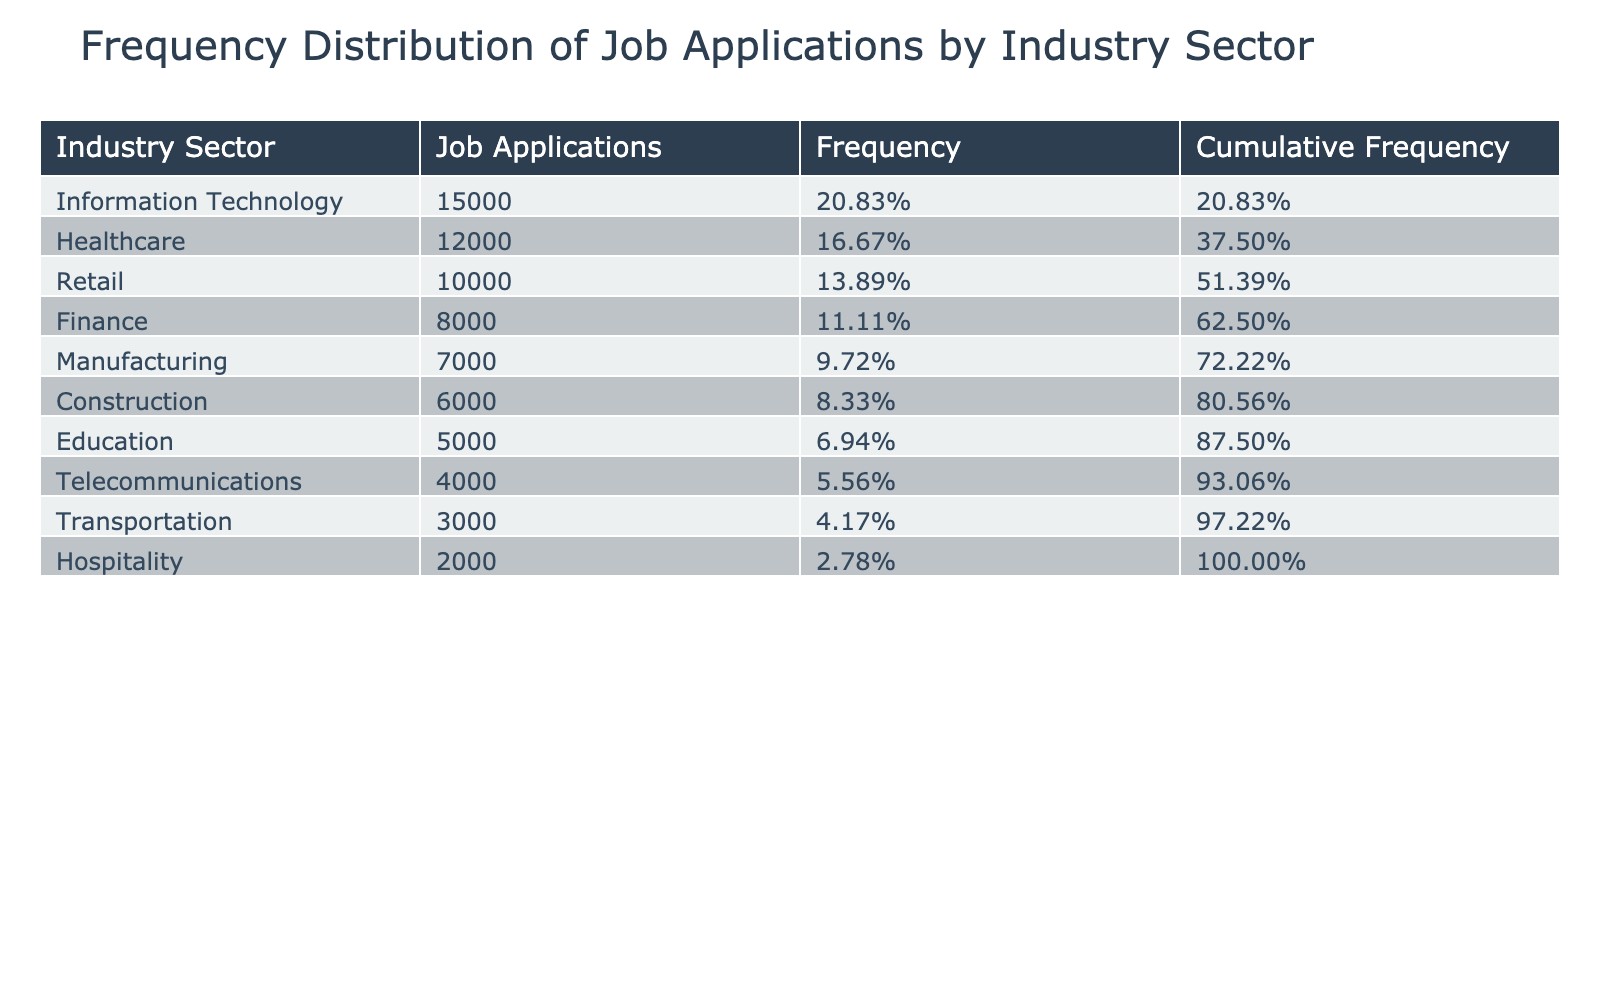What is the industry sector that received the highest number of job applications? According to the table, the highest number of job applications is for Information Technology with 15,000 applications.
Answer: Information Technology How many job applications were received in the healthcare sector? The table shows that the healthcare sector received 12,000 job applications.
Answer: 12,000 What is the frequency of job applications received by the finance sector? The total number of applications is 70,000 (15,000 + 12,000 + 8,000 + 7,000 + 10,000 + 6,000 + 5,000 + 4,000 + 3,000 + 2,000). The finance sector received 8,000 applications, so the frequency is 8,000/70,000 = 0.1143, which is approximately 11.43%.
Answer: 11.43% Which industry sectors received more than 10,000 job applications? The sectors with more than 10,000 applications are Information Technology (15,000) and healthcare (12,000).
Answer: Information Technology and Healthcare What is the cumulative frequency of job applications received by the retail sector? The retail sector is the fifth largest in terms of applications. The cumulative frequency is calculated by adding the frequencies of all previous sectors. So, cumulative frequency for retail is the sum of frequencies of Information Technology, Healthcare, Finance, and Manufacturing, plus its own frequency. This equals 0.2143 + 0.1714 + 0.1143 + 0.1 + 0.1429 = 0.7857 or 78.57%.
Answer: 78.57% Is the number of job applications received in the transportation sector greater than that in the hospitality sector? The transportation sector received 3,000 applications, while the hospitality sector received 2,000 applications. Since 3,000 is greater than 2,000, the statement is true.
Answer: Yes What is the total number of job applications received across all sectors? By summing all the job applications from each sector: 15,000 + 12,000 + 8,000 + 7,000 + 10,000 + 6,000 + 5,000 + 4,000 + 3,000 + 2,000 = 68,000.
Answer: 68,000 Which sector received the least number of job applications? The sector with the least applications is hospitality, with only 2,000 applications received.
Answer: Hospitality If we were to remove the education sector from the total, what would be the new total number of job applications? The initial total is 68,000. The education sector received 5,000 applications. If we remove this, the new total is 68,000 - 5,000 = 63,000.
Answer: 63,000 